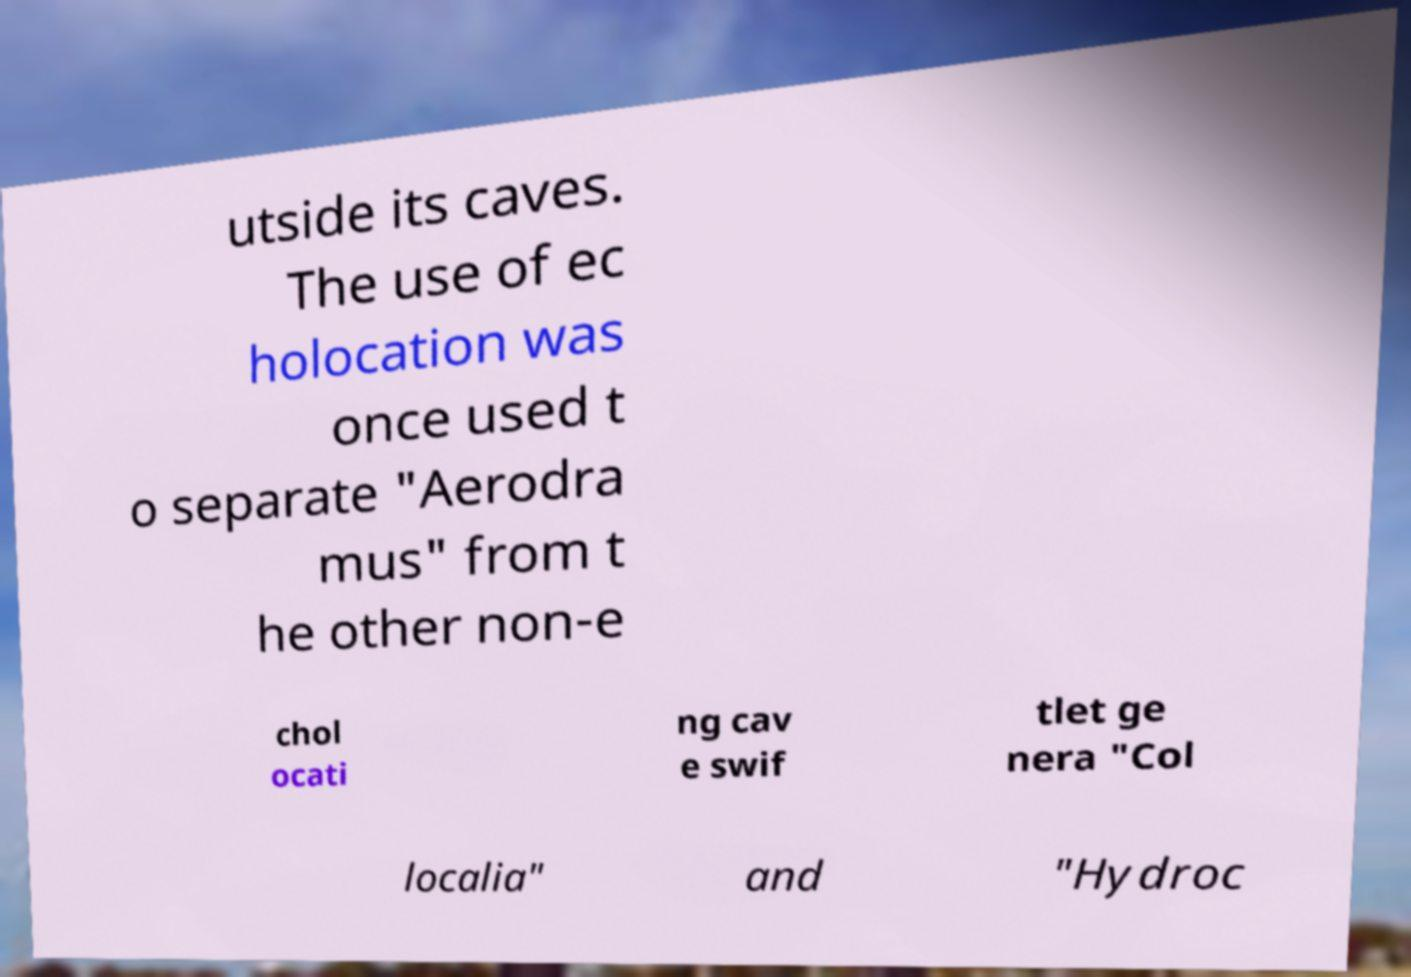Please identify and transcribe the text found in this image. utside its caves. The use of ec holocation was once used t o separate "Aerodra mus" from t he other non-e chol ocati ng cav e swif tlet ge nera "Col localia" and "Hydroc 